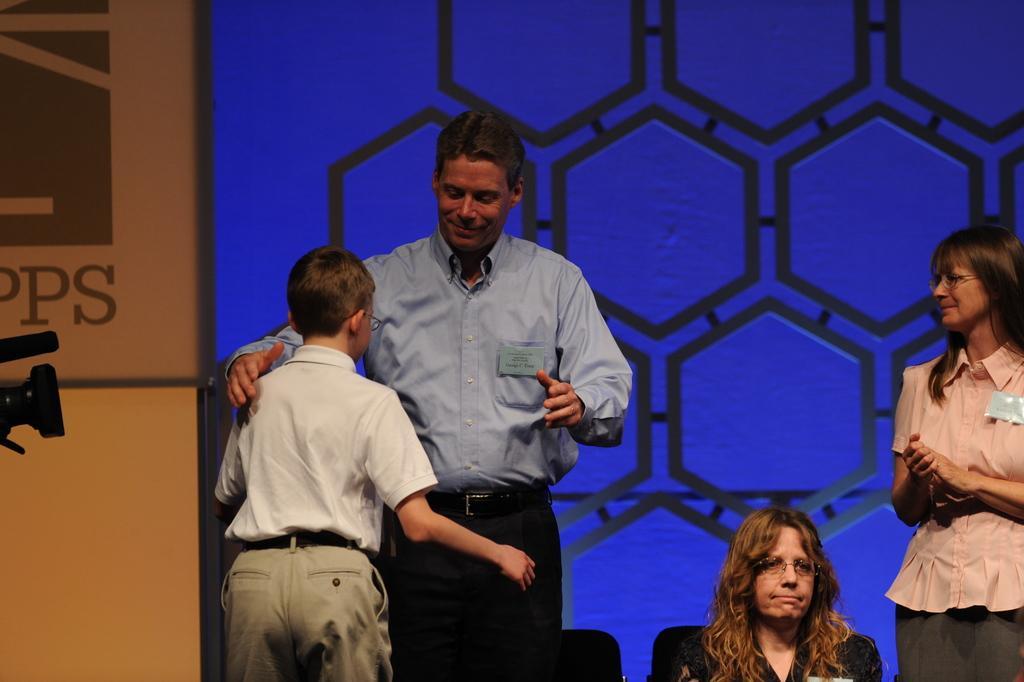Could you give a brief overview of what you see in this image? In the bottom left corner of the image a woman is sitting and few people are standing and smiling. Behind them we can see a wall. On the left side of the image we can see a camera. 